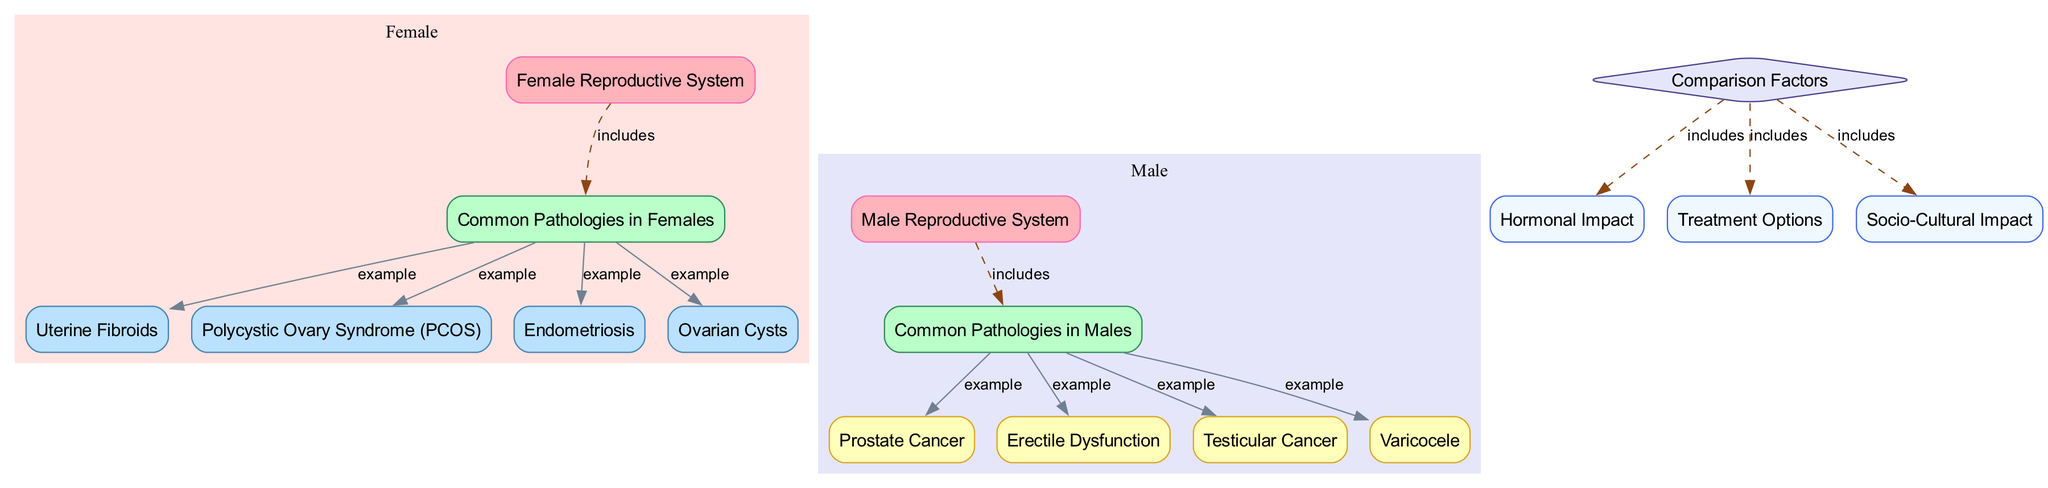What are the examples of pathologies in females? The diagram lists four examples of pathologies in females under the "Common Pathologies in Females" node. These examples are connected with "example" edges, explicitly labeled as "Uterine Fibroids," "Polycystic Ovary Syndrome (PCOS)," "Endometriosis," and "Ovarian Cysts."
Answer: Uterine Fibroids, Polycystic Ovary Syndrome (PCOS), Endometriosis, Ovarian Cysts How many common pathologies are listed for males? The diagram shows four examples of common pathologies listed under the "Common Pathologies in Males" node. These are connected via "example" edges to the "pathologies_male" node, which provides a total of "Prostate Cancer," "Erectile Dysfunction," "Testicular Cancer," and "Varicocele."
Answer: 4 What factor is included in the comparison between male and female pathologies? The "Comparison Factors" node connects several nodes, and one of these is "Hormonal Impact," which pertains to the different hormonal influences on male and female reproductive systems and their respective pathologies.
Answer: Hormonal Impact Which pathology is associated with erectile dysfunction? Within the diagram under the "Common Pathologies in Males" node, the "Erectile Dysfunction" node directly demonstrates its association as a significant male pathology, linked by an "example" edge.
Answer: Erectile Dysfunction What color represents the female reproductive system in this diagram? The "Female Reproductive System" node is distinguished in the diagram with a pink color, indicated by the fill color #FFB3BA and a border color of #FF69B4, differentiating it visually from male-related nodes.
Answer: Pink How many nodes are related to pathologies in the male reproductive system? The diagram clearly shows that four nodes related to specific pathologies are connected to the "pathologies_male" node: "Prostate Cancer," "Erectile Dysfunction," "Testicular Cancer," and "Varicocele," affirming a count of four pathologies.
Answer: 4 What treatment-related information is suggested for comparison? The "Comparison Factors" node lists "Treatment Options" as one of the important areas being compared between the male and female reproductive pathologies, signifying that this is relevant for analysis.
Answer: Treatment Options How are common pathologies in females and males visually distinguished? In the diagram, the "Common Pathologies in Females" nodes are filled with a light blue (#BAE1FF) color, while the "Common Pathologies in Males" nodes have a pale yellow (#FFFFBA) background, providing a clear visual distinction.
Answer: By color filling Which pathology in males is linked to cancer? The "Prostate Cancer" and "Testicular Cancer" nodes are both linked to the "Common Pathologies in Males" node, indicating that they are recognized male pathologies related to cancer.
Answer: Prostate Cancer, Testicular Cancer 